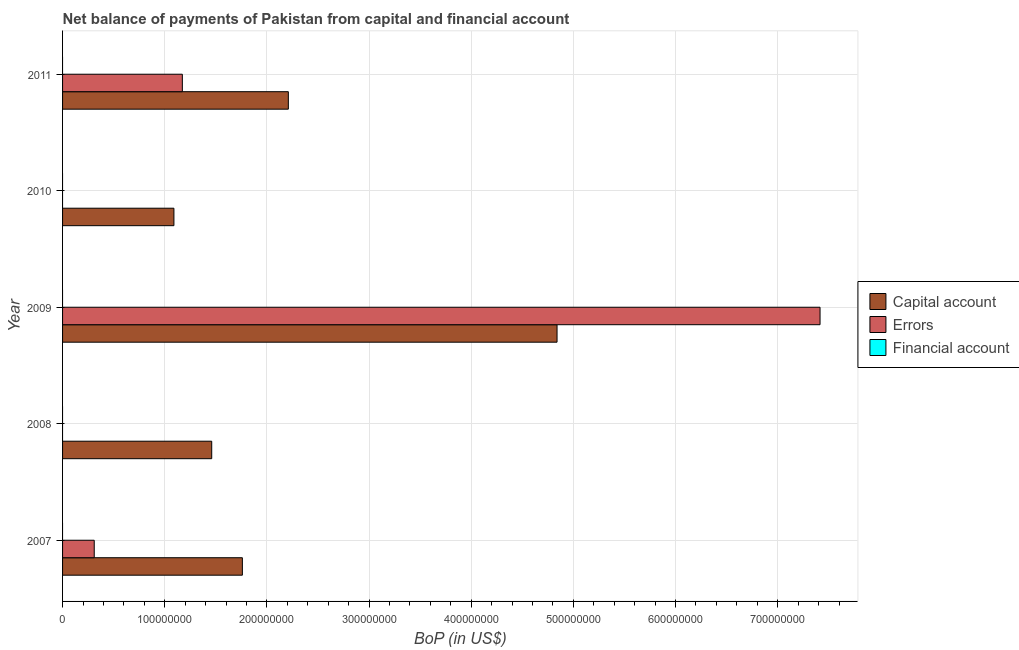How many different coloured bars are there?
Make the answer very short. 2. Are the number of bars per tick equal to the number of legend labels?
Keep it short and to the point. No. How many bars are there on the 3rd tick from the top?
Provide a succinct answer. 2. How many bars are there on the 4th tick from the bottom?
Your response must be concise. 1. What is the label of the 2nd group of bars from the top?
Make the answer very short. 2010. In how many cases, is the number of bars for a given year not equal to the number of legend labels?
Make the answer very short. 5. What is the amount of errors in 2008?
Provide a succinct answer. 0. Across all years, what is the maximum amount of errors?
Make the answer very short. 7.41e+08. Across all years, what is the minimum amount of net capital account?
Your answer should be very brief. 1.09e+08. What is the total amount of errors in the graph?
Offer a terse response. 8.90e+08. What is the difference between the amount of net capital account in 2008 and that in 2010?
Make the answer very short. 3.70e+07. What is the difference between the amount of financial account in 2011 and the amount of net capital account in 2010?
Make the answer very short. -1.09e+08. In how many years, is the amount of financial account greater than 80000000 US$?
Keep it short and to the point. 0. What is the ratio of the amount of errors in 2007 to that in 2009?
Offer a terse response. 0.04. Is the amount of net capital account in 2008 less than that in 2011?
Your answer should be very brief. Yes. What is the difference between the highest and the second highest amount of net capital account?
Provide a succinct answer. 2.63e+08. What is the difference between the highest and the lowest amount of errors?
Give a very brief answer. 7.41e+08. In how many years, is the amount of financial account greater than the average amount of financial account taken over all years?
Your response must be concise. 0. Is the sum of the amount of net capital account in 2008 and 2010 greater than the maximum amount of financial account across all years?
Provide a succinct answer. Yes. How many bars are there?
Your answer should be very brief. 8. How many years are there in the graph?
Offer a terse response. 5. What is the difference between two consecutive major ticks on the X-axis?
Offer a very short reply. 1.00e+08. Does the graph contain grids?
Provide a succinct answer. Yes. How many legend labels are there?
Offer a terse response. 3. How are the legend labels stacked?
Offer a terse response. Vertical. What is the title of the graph?
Keep it short and to the point. Net balance of payments of Pakistan from capital and financial account. Does "Liquid fuel" appear as one of the legend labels in the graph?
Your answer should be compact. No. What is the label or title of the X-axis?
Give a very brief answer. BoP (in US$). What is the label or title of the Y-axis?
Offer a very short reply. Year. What is the BoP (in US$) of Capital account in 2007?
Give a very brief answer. 1.76e+08. What is the BoP (in US$) in Errors in 2007?
Your answer should be very brief. 3.10e+07. What is the BoP (in US$) in Financial account in 2007?
Keep it short and to the point. 0. What is the BoP (in US$) in Capital account in 2008?
Provide a succinct answer. 1.46e+08. What is the BoP (in US$) in Financial account in 2008?
Offer a very short reply. 0. What is the BoP (in US$) of Capital account in 2009?
Provide a short and direct response. 4.84e+08. What is the BoP (in US$) of Errors in 2009?
Offer a very short reply. 7.41e+08. What is the BoP (in US$) in Capital account in 2010?
Ensure brevity in your answer.  1.09e+08. What is the BoP (in US$) of Errors in 2010?
Keep it short and to the point. 0. What is the BoP (in US$) in Capital account in 2011?
Your response must be concise. 2.21e+08. What is the BoP (in US$) in Errors in 2011?
Make the answer very short. 1.17e+08. Across all years, what is the maximum BoP (in US$) in Capital account?
Your response must be concise. 4.84e+08. Across all years, what is the maximum BoP (in US$) of Errors?
Ensure brevity in your answer.  7.41e+08. Across all years, what is the minimum BoP (in US$) in Capital account?
Your answer should be compact. 1.09e+08. Across all years, what is the minimum BoP (in US$) of Errors?
Provide a succinct answer. 0. What is the total BoP (in US$) in Capital account in the graph?
Your answer should be very brief. 1.14e+09. What is the total BoP (in US$) in Errors in the graph?
Offer a very short reply. 8.90e+08. What is the total BoP (in US$) in Financial account in the graph?
Give a very brief answer. 0. What is the difference between the BoP (in US$) in Capital account in 2007 and that in 2008?
Your response must be concise. 3.00e+07. What is the difference between the BoP (in US$) of Capital account in 2007 and that in 2009?
Your answer should be compact. -3.08e+08. What is the difference between the BoP (in US$) of Errors in 2007 and that in 2009?
Your response must be concise. -7.10e+08. What is the difference between the BoP (in US$) of Capital account in 2007 and that in 2010?
Give a very brief answer. 6.70e+07. What is the difference between the BoP (in US$) of Capital account in 2007 and that in 2011?
Offer a very short reply. -4.50e+07. What is the difference between the BoP (in US$) of Errors in 2007 and that in 2011?
Offer a terse response. -8.62e+07. What is the difference between the BoP (in US$) in Capital account in 2008 and that in 2009?
Your answer should be very brief. -3.38e+08. What is the difference between the BoP (in US$) in Capital account in 2008 and that in 2010?
Keep it short and to the point. 3.70e+07. What is the difference between the BoP (in US$) of Capital account in 2008 and that in 2011?
Provide a short and direct response. -7.50e+07. What is the difference between the BoP (in US$) of Capital account in 2009 and that in 2010?
Provide a succinct answer. 3.75e+08. What is the difference between the BoP (in US$) of Capital account in 2009 and that in 2011?
Keep it short and to the point. 2.63e+08. What is the difference between the BoP (in US$) of Errors in 2009 and that in 2011?
Give a very brief answer. 6.24e+08. What is the difference between the BoP (in US$) in Capital account in 2010 and that in 2011?
Your response must be concise. -1.12e+08. What is the difference between the BoP (in US$) in Capital account in 2007 and the BoP (in US$) in Errors in 2009?
Offer a terse response. -5.65e+08. What is the difference between the BoP (in US$) in Capital account in 2007 and the BoP (in US$) in Errors in 2011?
Provide a succinct answer. 5.88e+07. What is the difference between the BoP (in US$) of Capital account in 2008 and the BoP (in US$) of Errors in 2009?
Offer a very short reply. -5.95e+08. What is the difference between the BoP (in US$) in Capital account in 2008 and the BoP (in US$) in Errors in 2011?
Make the answer very short. 2.88e+07. What is the difference between the BoP (in US$) of Capital account in 2009 and the BoP (in US$) of Errors in 2011?
Provide a succinct answer. 3.67e+08. What is the difference between the BoP (in US$) of Capital account in 2010 and the BoP (in US$) of Errors in 2011?
Keep it short and to the point. -8.25e+06. What is the average BoP (in US$) of Capital account per year?
Your response must be concise. 2.27e+08. What is the average BoP (in US$) in Errors per year?
Provide a short and direct response. 1.78e+08. In the year 2007, what is the difference between the BoP (in US$) in Capital account and BoP (in US$) in Errors?
Give a very brief answer. 1.45e+08. In the year 2009, what is the difference between the BoP (in US$) of Capital account and BoP (in US$) of Errors?
Your response must be concise. -2.57e+08. In the year 2011, what is the difference between the BoP (in US$) of Capital account and BoP (in US$) of Errors?
Your response must be concise. 1.04e+08. What is the ratio of the BoP (in US$) of Capital account in 2007 to that in 2008?
Ensure brevity in your answer.  1.21. What is the ratio of the BoP (in US$) in Capital account in 2007 to that in 2009?
Give a very brief answer. 0.36. What is the ratio of the BoP (in US$) of Errors in 2007 to that in 2009?
Your answer should be compact. 0.04. What is the ratio of the BoP (in US$) of Capital account in 2007 to that in 2010?
Make the answer very short. 1.61. What is the ratio of the BoP (in US$) of Capital account in 2007 to that in 2011?
Make the answer very short. 0.8. What is the ratio of the BoP (in US$) of Errors in 2007 to that in 2011?
Give a very brief answer. 0.26. What is the ratio of the BoP (in US$) in Capital account in 2008 to that in 2009?
Provide a short and direct response. 0.3. What is the ratio of the BoP (in US$) of Capital account in 2008 to that in 2010?
Provide a succinct answer. 1.34. What is the ratio of the BoP (in US$) in Capital account in 2008 to that in 2011?
Keep it short and to the point. 0.66. What is the ratio of the BoP (in US$) of Capital account in 2009 to that in 2010?
Give a very brief answer. 4.44. What is the ratio of the BoP (in US$) of Capital account in 2009 to that in 2011?
Make the answer very short. 2.19. What is the ratio of the BoP (in US$) in Errors in 2009 to that in 2011?
Make the answer very short. 6.32. What is the ratio of the BoP (in US$) of Capital account in 2010 to that in 2011?
Give a very brief answer. 0.49. What is the difference between the highest and the second highest BoP (in US$) in Capital account?
Your response must be concise. 2.63e+08. What is the difference between the highest and the second highest BoP (in US$) of Errors?
Your answer should be compact. 6.24e+08. What is the difference between the highest and the lowest BoP (in US$) of Capital account?
Provide a succinct answer. 3.75e+08. What is the difference between the highest and the lowest BoP (in US$) of Errors?
Provide a short and direct response. 7.41e+08. 